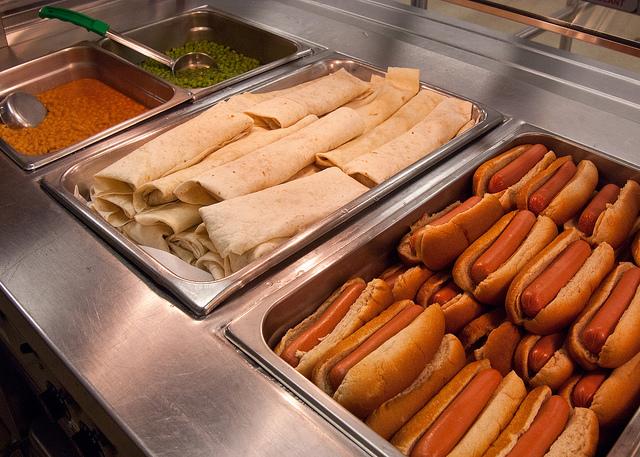How many hot dogs are ready to eat?
Quick response, please. 20. Where is the hot dogs?
Quick response, please. On right. How many toppings are there?
Give a very brief answer. 2. What color is the ladle handle?
Answer briefly. Green. 